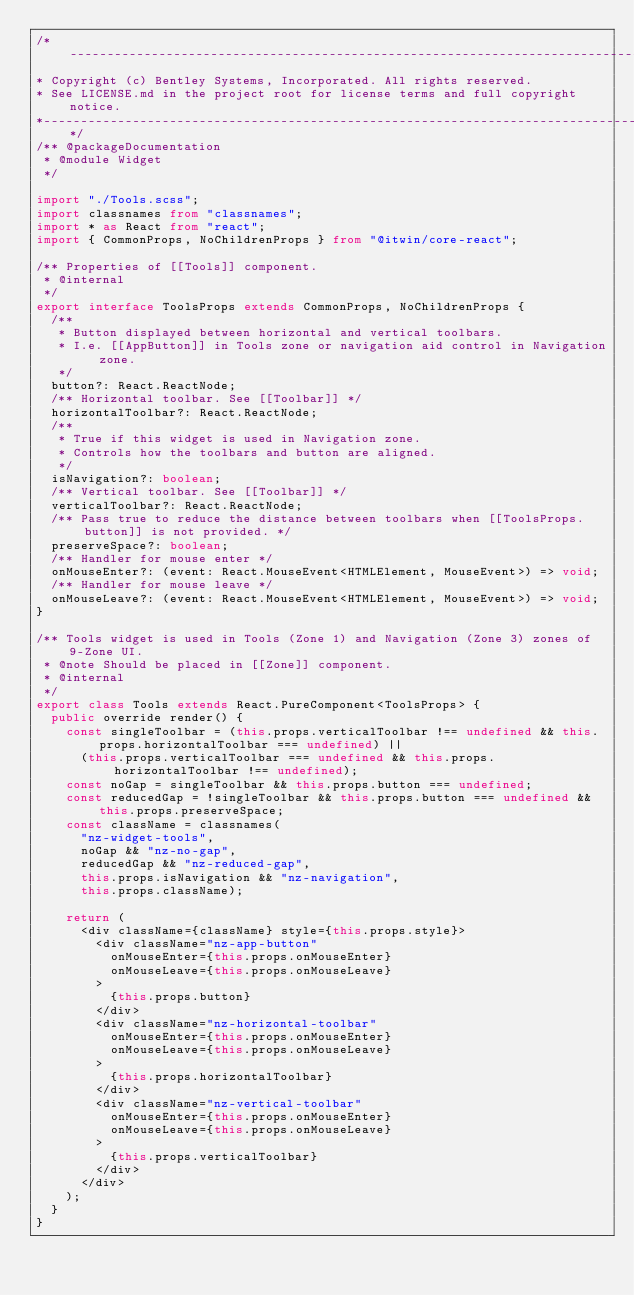<code> <loc_0><loc_0><loc_500><loc_500><_TypeScript_>/*---------------------------------------------------------------------------------------------
* Copyright (c) Bentley Systems, Incorporated. All rights reserved.
* See LICENSE.md in the project root for license terms and full copyright notice.
*--------------------------------------------------------------------------------------------*/
/** @packageDocumentation
 * @module Widget
 */

import "./Tools.scss";
import classnames from "classnames";
import * as React from "react";
import { CommonProps, NoChildrenProps } from "@itwin/core-react";

/** Properties of [[Tools]] component.
 * @internal
 */
export interface ToolsProps extends CommonProps, NoChildrenProps {
  /**
   * Button displayed between horizontal and vertical toolbars.
   * I.e. [[AppButton]] in Tools zone or navigation aid control in Navigation zone.
   */
  button?: React.ReactNode;
  /** Horizontal toolbar. See [[Toolbar]] */
  horizontalToolbar?: React.ReactNode;
  /**
   * True if this widget is used in Navigation zone.
   * Controls how the toolbars and button are aligned.
   */
  isNavigation?: boolean;
  /** Vertical toolbar. See [[Toolbar]] */
  verticalToolbar?: React.ReactNode;
  /** Pass true to reduce the distance between toolbars when [[ToolsProps.button]] is not provided. */
  preserveSpace?: boolean;
  /** Handler for mouse enter */
  onMouseEnter?: (event: React.MouseEvent<HTMLElement, MouseEvent>) => void;
  /** Handler for mouse leave */
  onMouseLeave?: (event: React.MouseEvent<HTMLElement, MouseEvent>) => void;
}

/** Tools widget is used in Tools (Zone 1) and Navigation (Zone 3) zones of 9-Zone UI.
 * @note Should be placed in [[Zone]] component.
 * @internal
 */
export class Tools extends React.PureComponent<ToolsProps> {
  public override render() {
    const singleToolbar = (this.props.verticalToolbar !== undefined && this.props.horizontalToolbar === undefined) ||
      (this.props.verticalToolbar === undefined && this.props.horizontalToolbar !== undefined);
    const noGap = singleToolbar && this.props.button === undefined;
    const reducedGap = !singleToolbar && this.props.button === undefined && this.props.preserveSpace;
    const className = classnames(
      "nz-widget-tools",
      noGap && "nz-no-gap",
      reducedGap && "nz-reduced-gap",
      this.props.isNavigation && "nz-navigation",
      this.props.className);

    return (
      <div className={className} style={this.props.style}>
        <div className="nz-app-button"
          onMouseEnter={this.props.onMouseEnter}
          onMouseLeave={this.props.onMouseLeave}
        >
          {this.props.button}
        </div>
        <div className="nz-horizontal-toolbar"
          onMouseEnter={this.props.onMouseEnter}
          onMouseLeave={this.props.onMouseLeave}
        >
          {this.props.horizontalToolbar}
        </div>
        <div className="nz-vertical-toolbar"
          onMouseEnter={this.props.onMouseEnter}
          onMouseLeave={this.props.onMouseLeave}
        >
          {this.props.verticalToolbar}
        </div>
      </div>
    );
  }
}
</code> 